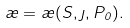Convert formula to latex. <formula><loc_0><loc_0><loc_500><loc_500>\rho = \rho ( S , \eta , P _ { 0 } ) .</formula> 